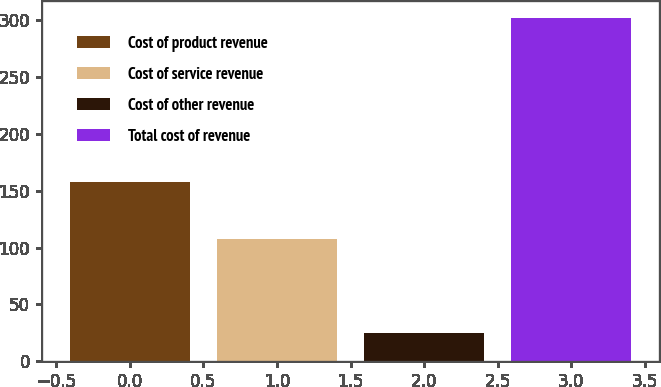<chart> <loc_0><loc_0><loc_500><loc_500><bar_chart><fcel>Cost of product revenue<fcel>Cost of service revenue<fcel>Cost of other revenue<fcel>Total cost of revenue<nl><fcel>157.4<fcel>107.6<fcel>24.4<fcel>301.8<nl></chart> 